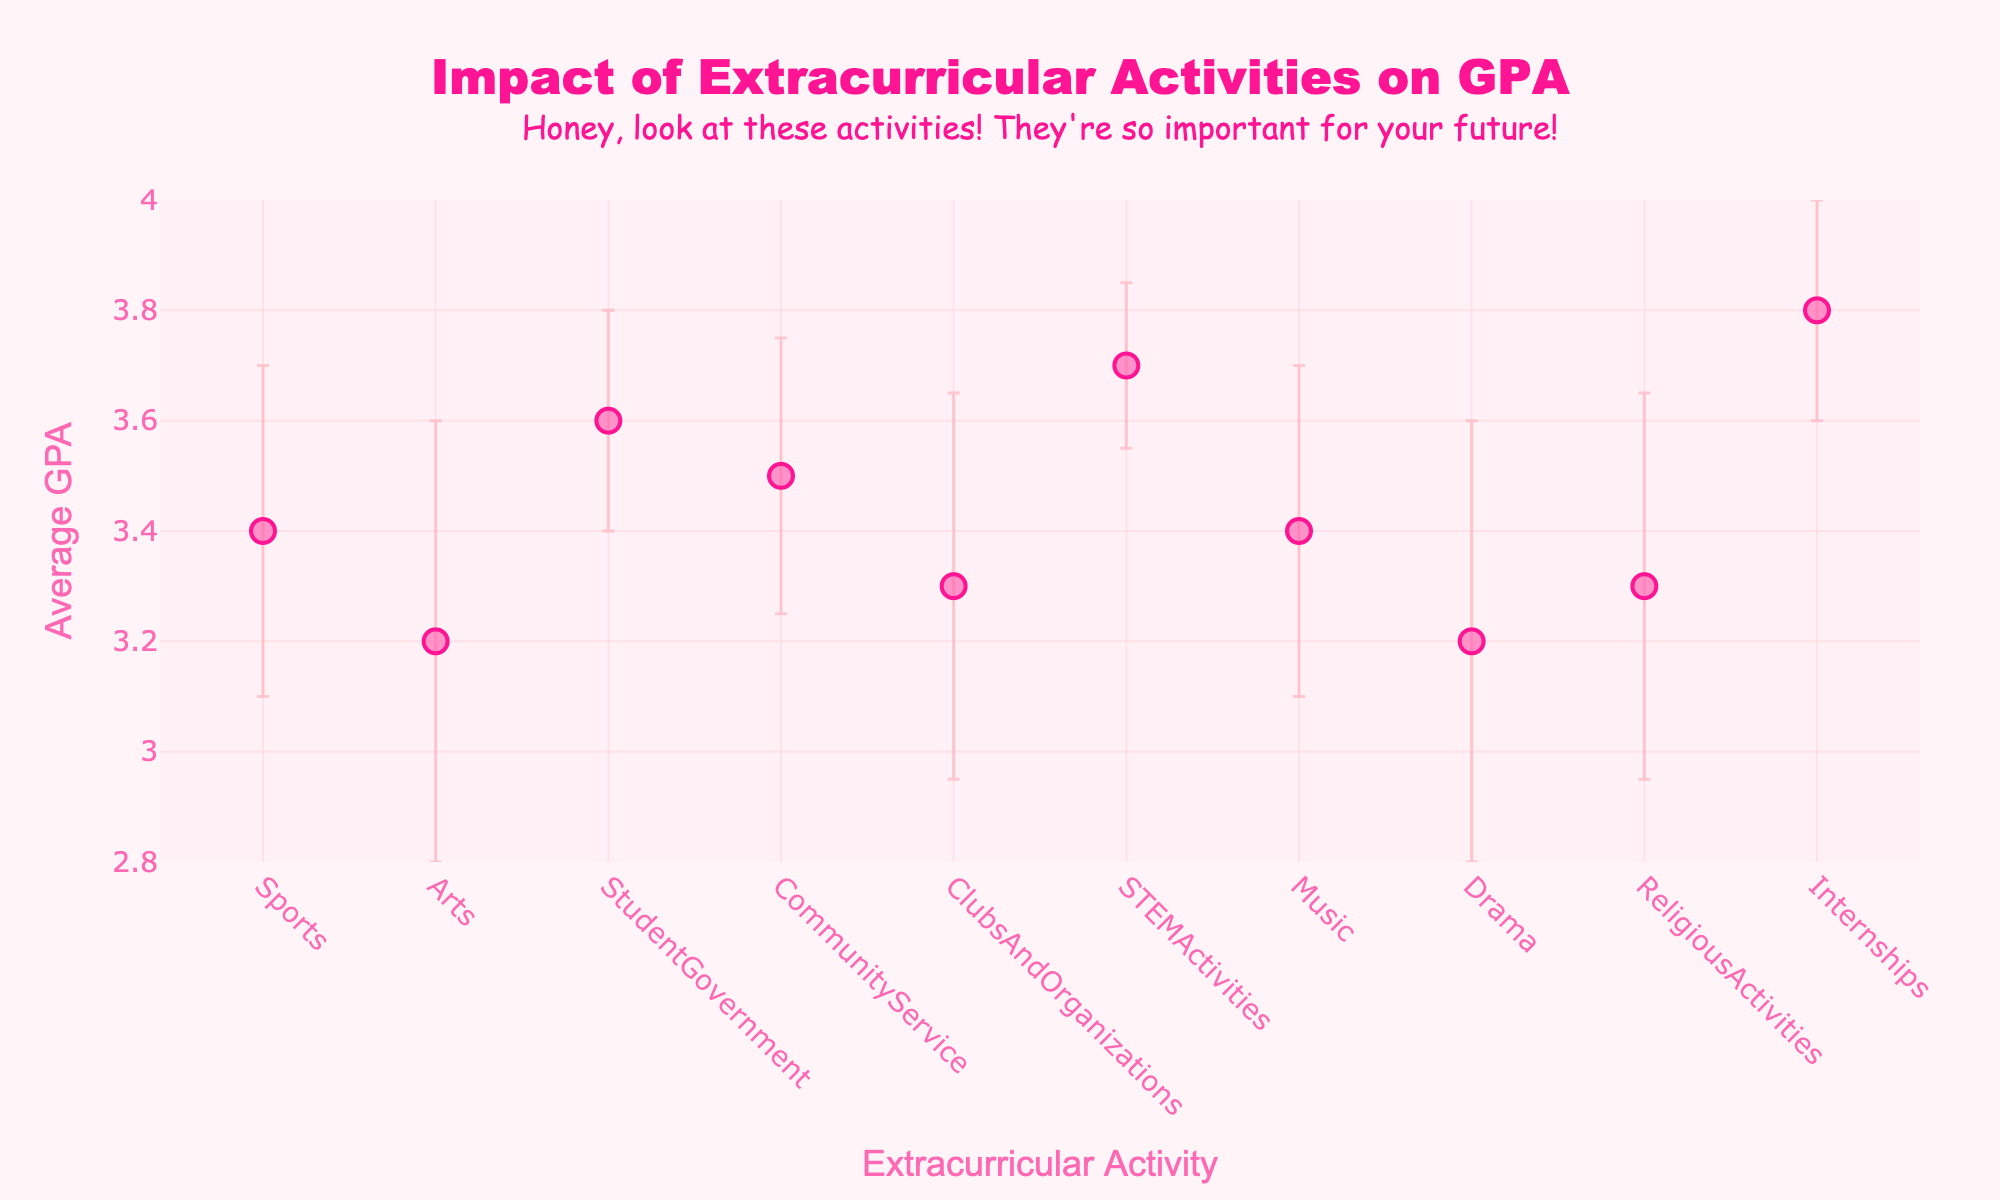What's the title of the plot? The title is the largest and most centrally located text at the top of the plot.
Answer: Impact of Extracurricular Activities on GPA Which extracurricular activity has the highest average GPA? Locate the point with the highest vertical position on the y-axis.
Answer: Internships What is the average GPA for Student Government activities? Look for the data point labeled "StudentGovernment" and check its corresponding y-axis value.
Answer: 3.6 Compare the average GPAs of Sports and Music activities. Which one is higher? Locate both points on the plot and compare their y-axis values.
Answer: Tie (both have 3.4) What are the error bars for Drama activities, and what do they represent? Find the data point labeled "Drama" and look at the vertical lines extending above and below it. These represent the standard deviation.
Answer: ±0.4 Which activities have the widest error bars, indicating the highest standard deviations? Look for the points with the longest vertical lines extending from them.
Answer: Arts, Drama Estimate the range of GPA values for STEM Activities, considering the error bars. Add and subtract the standard deviation from the average GPA for "STEMActivities": 3.7 ± 0.15.
Answer: 3.55 to 3.85 How does the average GPA for Community Service compare to that for Clubs and Organizations? Compare the y-axis values of the data points for "CommunityService" and "ClubsAndOrganizations".
Answer: Community Service is higher (3.5 vs. 3.3) What might be a reason for the relatively low average GPA for students involved in Arts activities? Error bars for Arts are wide, indicating high variability in GPA. The average GPA might be lower due to individual differences or the time commitment required.
Answer: High variability or time commitment 